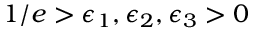Convert formula to latex. <formula><loc_0><loc_0><loc_500><loc_500>1 / e > \epsilon _ { 1 } , \epsilon _ { 2 } , \epsilon _ { 3 } > 0</formula> 